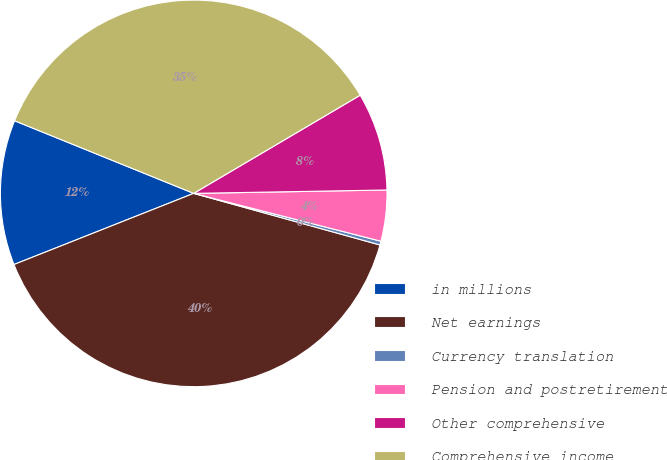<chart> <loc_0><loc_0><loc_500><loc_500><pie_chart><fcel>in millions<fcel>Net earnings<fcel>Currency translation<fcel>Pension and postretirement<fcel>Other comprehensive<fcel>Comprehensive income<nl><fcel>12.13%<fcel>39.7%<fcel>0.32%<fcel>4.26%<fcel>8.2%<fcel>35.39%<nl></chart> 